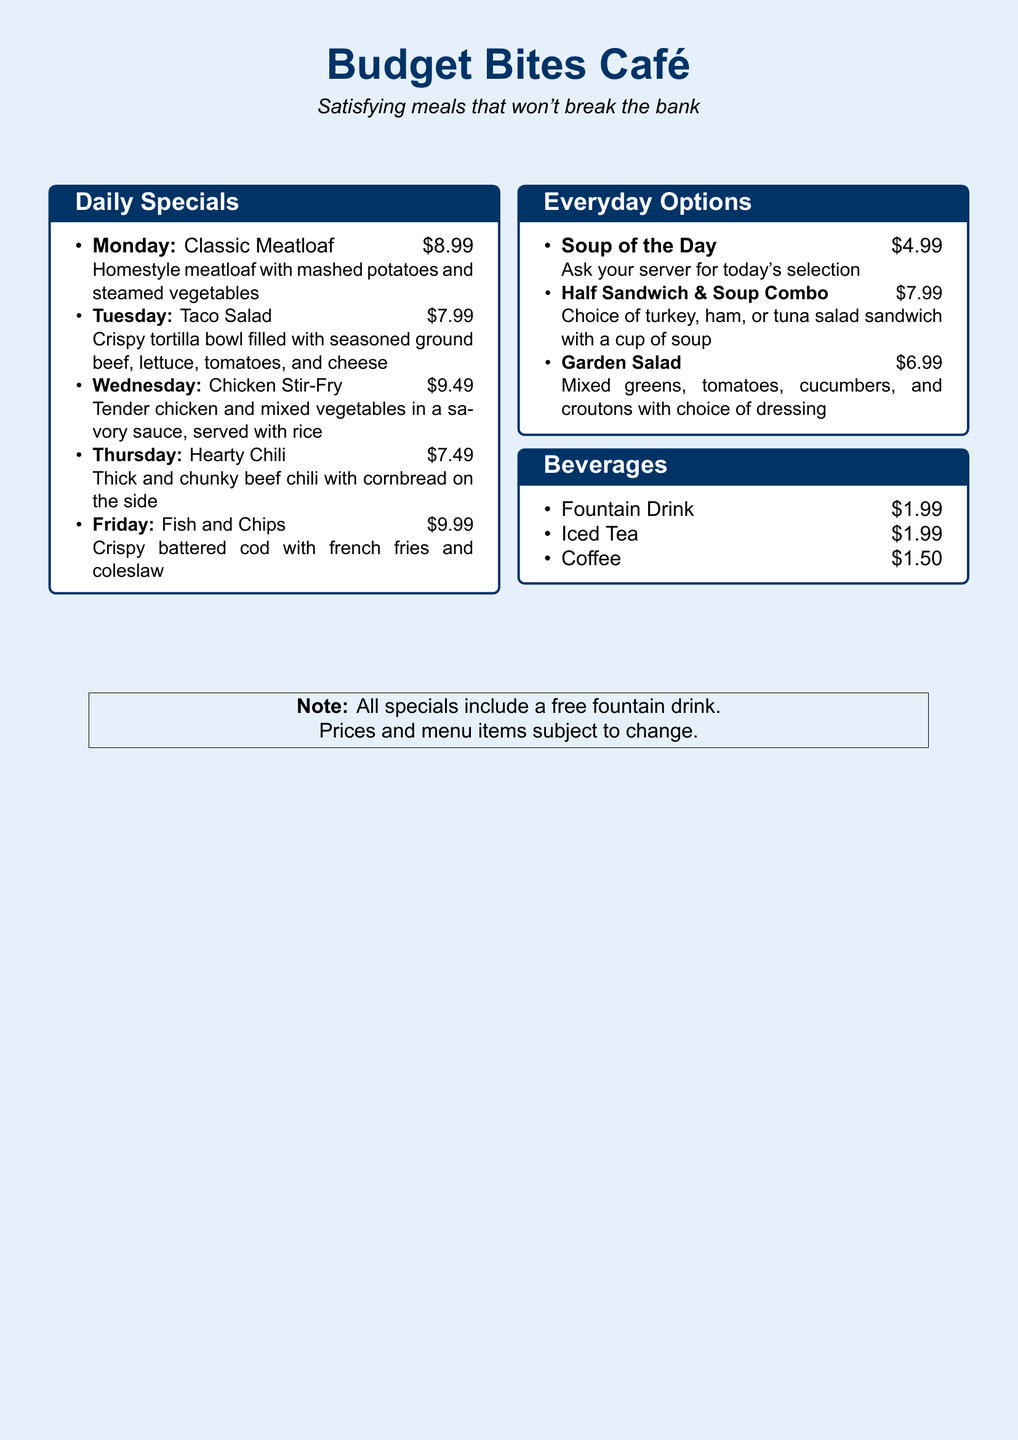What is the price of the Classic Meatloaf? The Classic Meatloaf is priced at $8.99, as stated in the Monday special.
Answer: $8.99 Which day features the Fish and Chips? The Fish and Chips special is available on Friday, as per the daily specials list.
Answer: Friday What is included with all weekday lunch specials? Each special includes a free fountain drink, as noted in the document.
Answer: Free fountain drink What is the price of the Soup of the Day? The price for the Soup of the Day is $4.99, as listed under Everyday Options.
Answer: $4.99 Which weekday special is the cheapest? The Hearty Chili at $7.49 is the cheapest option available on Thursday.
Answer: Hearty Chili How much does the Half Sandwich & Soup Combo cost? The combo is priced at $7.99, detailed in the Everyday Options section.
Answer: $7.99 What type of meal can you get on Wednesday? On Wednesday, you can enjoy Chicken Stir-Fry, as per the daily specials.
Answer: Chicken Stir-Fry What beverages are listed under the Beverages section? The beverages include Fountain Drink, Iced Tea, and Coffee as specified in the menu.
Answer: Fountain Drink, Iced Tea, Coffee 